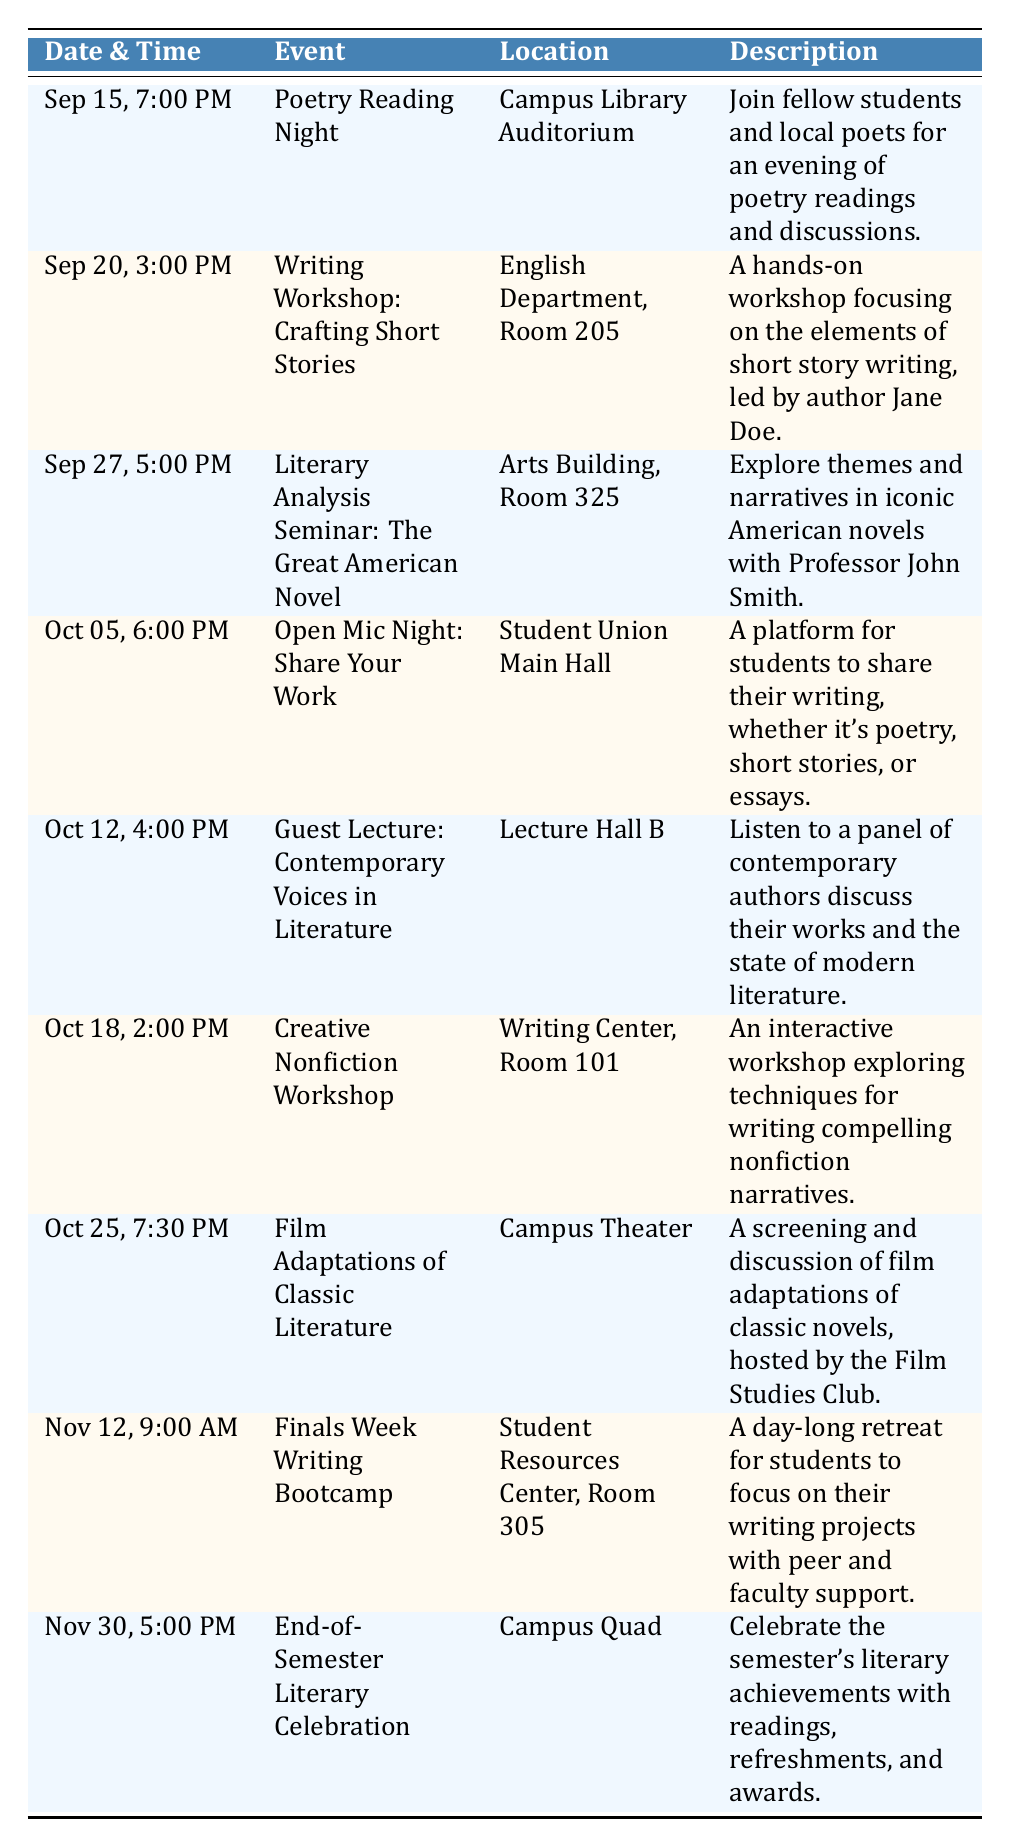What event takes place on October 18? According to the table, the event scheduled for October 18 is the "Creative Nonfiction Workshop" at 2:00 PM.
Answer: Creative Nonfiction Workshop What is the location for the "Finals Week Writing Bootcamp"? The "Finals Week Writing Bootcamp" is set to take place in the "Student Resources Center, Room 305" according to the table.
Answer: Student Resources Center, Room 305 How many events are scheduled in September? There are three events listed for September: "Poetry Reading Night" on September 15, "Writing Workshop: Crafting Short Stories" on September 20, and "Literary Analysis Seminar: The Great American Novel" on September 27. The total is 3.
Answer: 3 Which event occurs last in November? The last event in November is the "End-of-Semester Literary Celebration," which happens on November 30 at 5:00 PM according to the dates listed in the table.
Answer: End-of-Semester Literary Celebration Is there a writing workshop offered in October? Yes, there is a "Creative Nonfiction Workshop" scheduled for October 18.
Answer: Yes What is the time for the "Open Mic Night: Share Your Work"? The "Open Mic Night: Share Your Work" is scheduled for 6:00 PM on October 5 as per the table information.
Answer: 6:00 PM How many events are taking place in total? The table lists a total of eight distinct events scheduled from September through November, count listing each event confirms this total.
Answer: 8 Which events occur in the same week as the "Guest Lecture: Contemporary Voices in Literature"? The "Guest Lecture: Contemporary Voices in Literature" takes place on October 12. The only other event that week is the "Open Mic Night: Share Your Work" on October 5, making them both occurring in the same week.
Answer: Open Mic Night: Share Your Work What percentage of the events are focused on workshops? There are four workshops mentioned: "Writing Workshop: Crafting Short Stories," "Creative Nonfiction Workshop," and "Finals Week Writing Bootcamp," out of a total of eight events. The calculation for the percentage is (4/8) * 100 = 50%.
Answer: 50% 